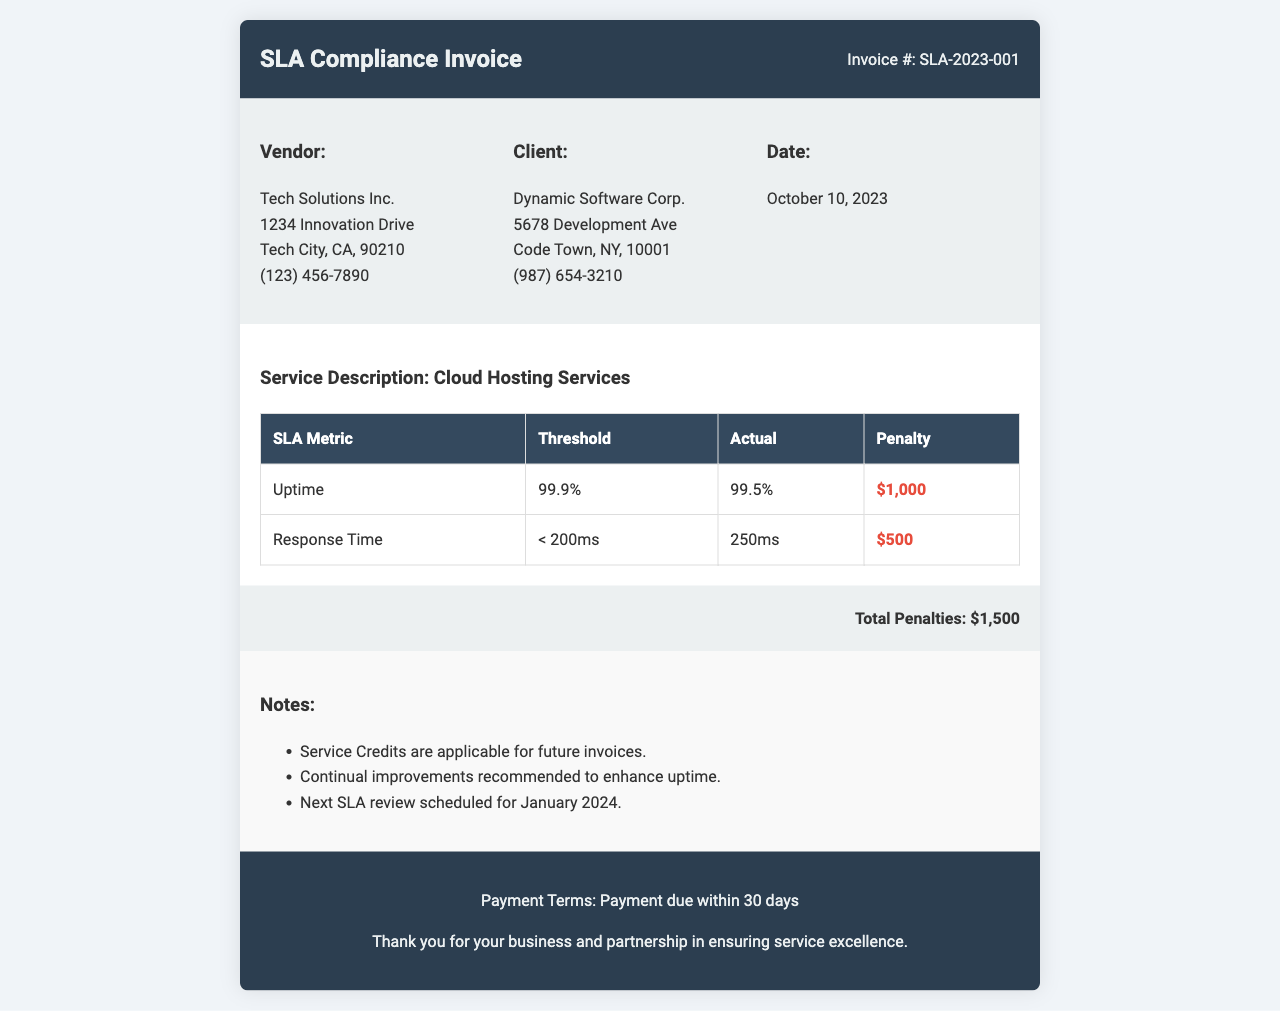What is the invoice number? The invoice number is labeled in the header of the document.
Answer: SLA-2023-001 Who is the vendor? The vendor's name is mentioned in the vendor section of the document.
Answer: Tech Solutions Inc What is the service description? The service description is stated in the service details section.
Answer: Cloud Hosting Services What is the actual uptime? The actual uptime is specified in the SLA metric table under the uptime row.
Answer: 99.5% What is the penalty for missed uptime? The penalty for missed uptime is shown in the SLA metric table under the uptime row.
Answer: $1,000 What is the total penalty amount? The total penalty amount is summarized at the bottom of the document.
Answer: $1,500 What is the response time threshold? The response time threshold is provided in the SLA metric table.
Answer: < 200ms When is the next SLA review scheduled? The next SLA review date is mentioned in the notes section of the document.
Answer: January 2024 What are the payment terms? The payment terms are stated in the footer of the invoice.
Answer: Payment due within 30 days 